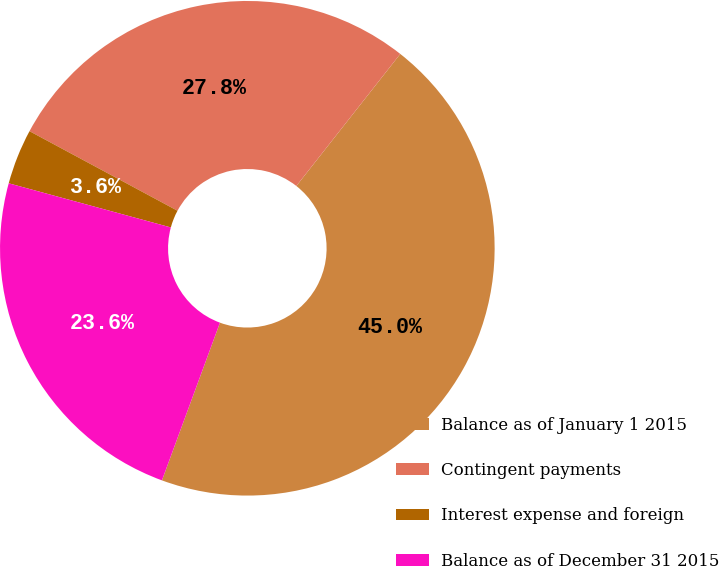Convert chart to OTSL. <chart><loc_0><loc_0><loc_500><loc_500><pie_chart><fcel>Balance as of January 1 2015<fcel>Contingent payments<fcel>Interest expense and foreign<fcel>Balance as of December 31 2015<nl><fcel>45.0%<fcel>27.76%<fcel>3.62%<fcel>23.62%<nl></chart> 